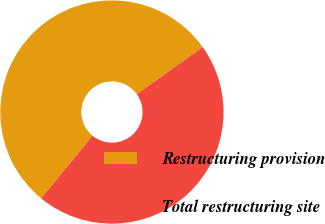Convert chart. <chart><loc_0><loc_0><loc_500><loc_500><pie_chart><fcel>Restructuring provision<fcel>Total restructuring site<nl><fcel>54.18%<fcel>45.82%<nl></chart> 